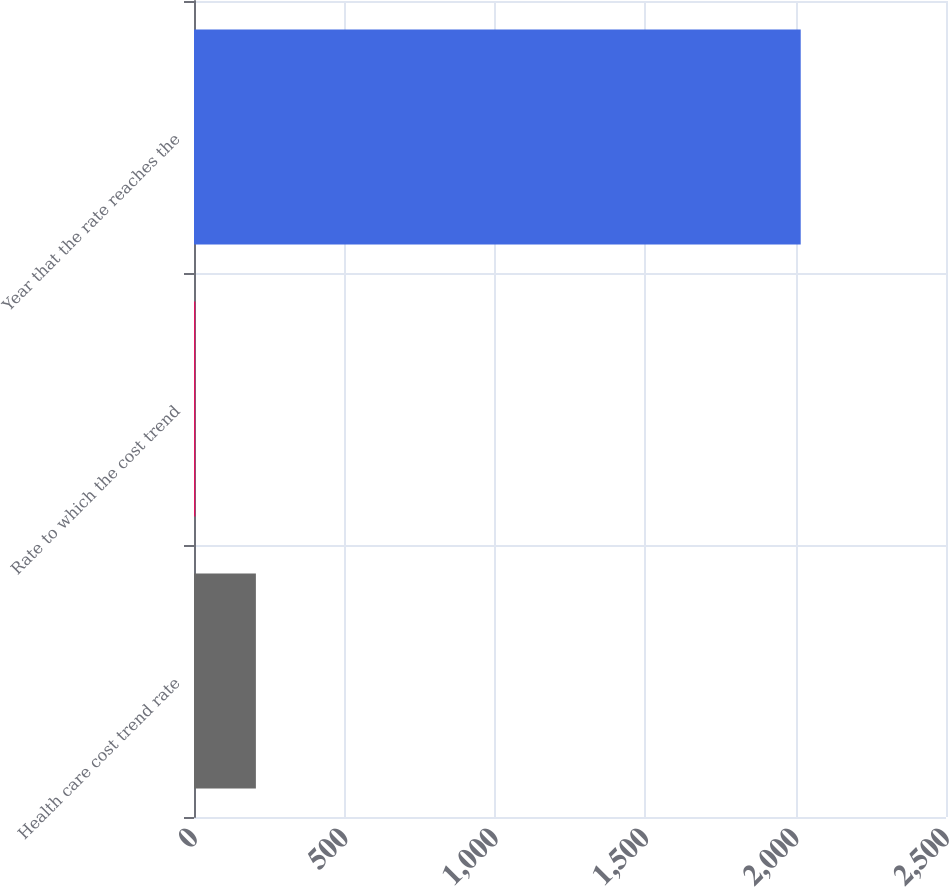<chart> <loc_0><loc_0><loc_500><loc_500><bar_chart><fcel>Health care cost trend rate<fcel>Rate to which the cost trend<fcel>Year that the rate reaches the<nl><fcel>205.75<fcel>4.5<fcel>2017<nl></chart> 